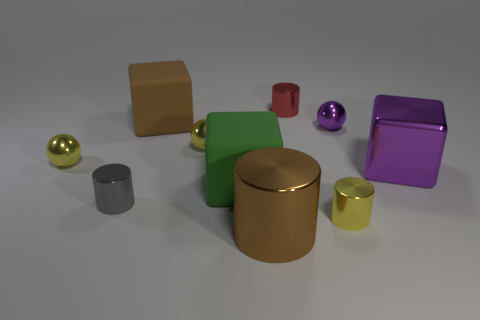How many large matte things are to the left of the brown cylinder? To the left of the brown cylinder, there are two large matte objects: a green cube and a red cube. These are characterized by their non-reflective surfaces that distinguish them from the other glossy items in the scene. 